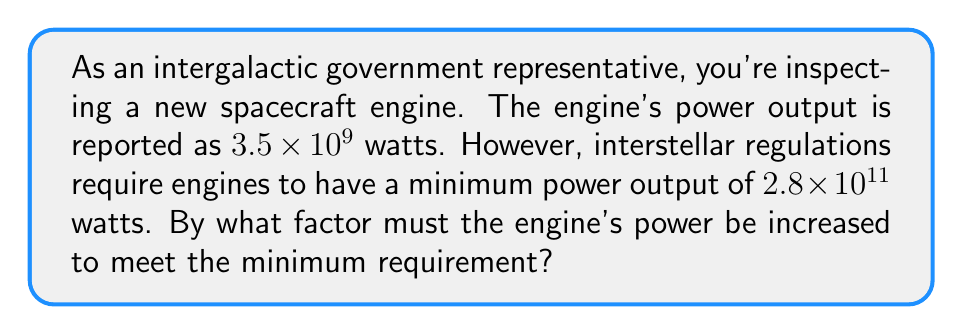Could you help me with this problem? To solve this problem, we need to follow these steps:

1) First, let's identify the given values:
   Current power output: $3.5 \times 10^9$ watts
   Required minimum power output: $2.8 \times 10^{11}$ watts

2) To find the factor by which the power must be increased, we need to divide the required power by the current power:

   $\frac{\text{Required Power}}{\text{Current Power}} = \frac{2.8 \times 10^{11}}{3.5 \times 10^9}$

3) When dividing numbers in scientific notation, we can divide the coefficients and subtract the exponents:

   $\frac{2.8}{3.5} \times 10^{11-9}$

4) Let's calculate this step by step:
   
   $\frac{2.8}{3.5} = 0.8$
   
   $11 - 9 = 2$

   So, our result is: $0.8 \times 10^2$

5) We can write this in standard form:

   $0.8 \times 10^2 = 80$

Therefore, the engine's power must be increased by a factor of 80 to meet the minimum requirement.
Answer: $80$ 